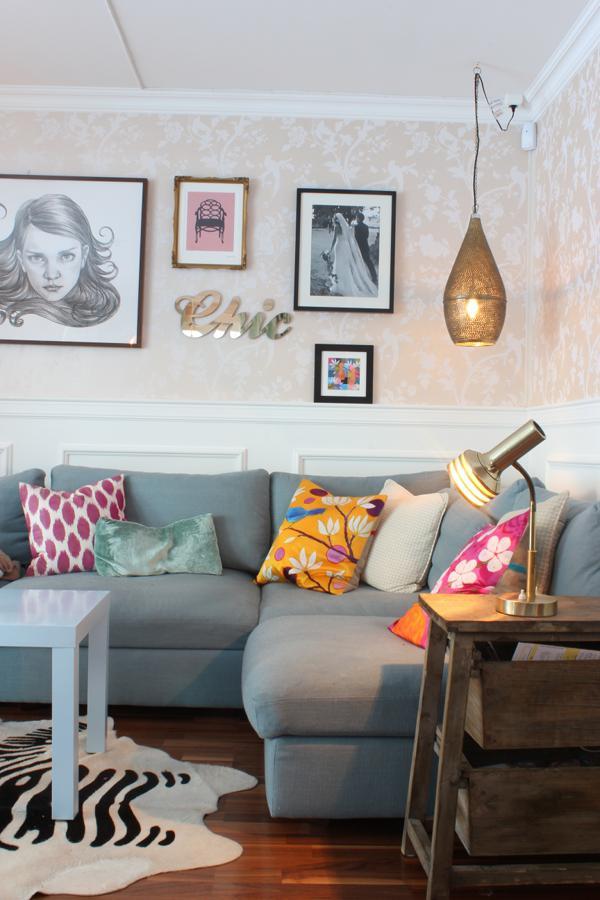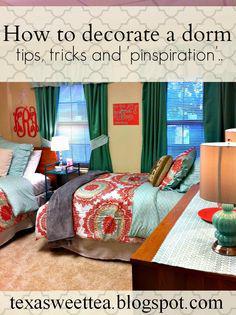The first image is the image on the left, the second image is the image on the right. Analyze the images presented: Is the assertion "At least one colorful pillow is displayed in front of a wall featuring round decorative items." valid? Answer yes or no. No. 